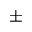Convert formula to latex. <formula><loc_0><loc_0><loc_500><loc_500>\pm</formula> 